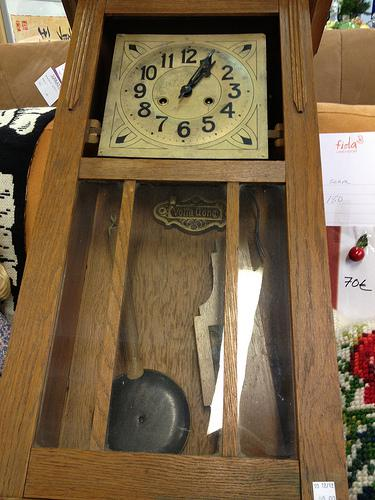Question: when is this?
Choices:
A. Now.
B. Soon.
C. Later.
D. 1:05.
Answer with the letter. Answer: D Question: why is it there?
Choices:
A. To tell time.
B. A decoration.
C. An heirloom.
D. To look at.
Answer with the letter. Answer: A Question: what is the clock made up?
Choices:
A. Glass.
B. Iron.
C. Plastic.
D. Wood.
Answer with the letter. Answer: D Question: what kind of clock is this?
Choices:
A. Kitchen.
B. Alarm.
C. Travel.
D. Grandfather.
Answer with the letter. Answer: D 